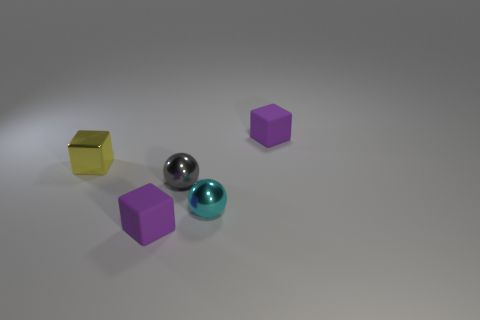Add 2 small gray objects. How many objects exist? 7 Subtract all tiny yellow shiny blocks. How many blocks are left? 2 Subtract all purple cylinders. How many purple blocks are left? 2 Subtract all yellow cubes. How many cubes are left? 2 Subtract 1 spheres. How many spheres are left? 1 Subtract all balls. How many objects are left? 3 Subtract 0 blue cubes. How many objects are left? 5 Subtract all cyan balls. Subtract all gray cylinders. How many balls are left? 1 Subtract all small cyan objects. Subtract all tiny shiny spheres. How many objects are left? 2 Add 3 blocks. How many blocks are left? 6 